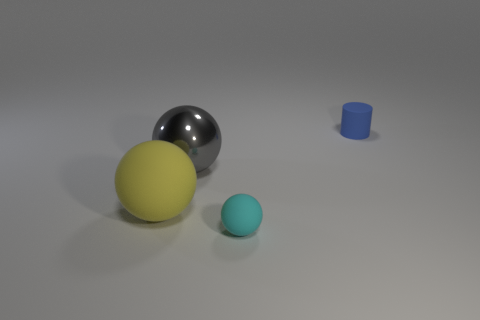Is the large shiny object the same color as the tiny ball?
Keep it short and to the point. No. There is a sphere that is the same size as the yellow rubber object; what is its color?
Your answer should be compact. Gray. Are there any other blue objects of the same shape as the large metallic thing?
Provide a succinct answer. No. There is a sphere in front of the big ball left of the large gray thing; are there any objects in front of it?
Keep it short and to the point. No. What is the shape of the yellow object that is the same size as the metallic ball?
Ensure brevity in your answer.  Sphere. What color is the tiny object that is the same shape as the big gray metallic thing?
Provide a short and direct response. Cyan. What number of things are either tiny blue cylinders or gray shiny objects?
Your answer should be very brief. 2. There is a small rubber thing in front of the tiny blue rubber cylinder; is it the same shape as the rubber object that is to the right of the small sphere?
Give a very brief answer. No. There is a small thing that is behind the small cyan thing; what is its shape?
Your answer should be compact. Cylinder. Is the number of yellow rubber balls to the right of the small blue cylinder the same as the number of small blue matte cylinders in front of the cyan ball?
Make the answer very short. Yes. 